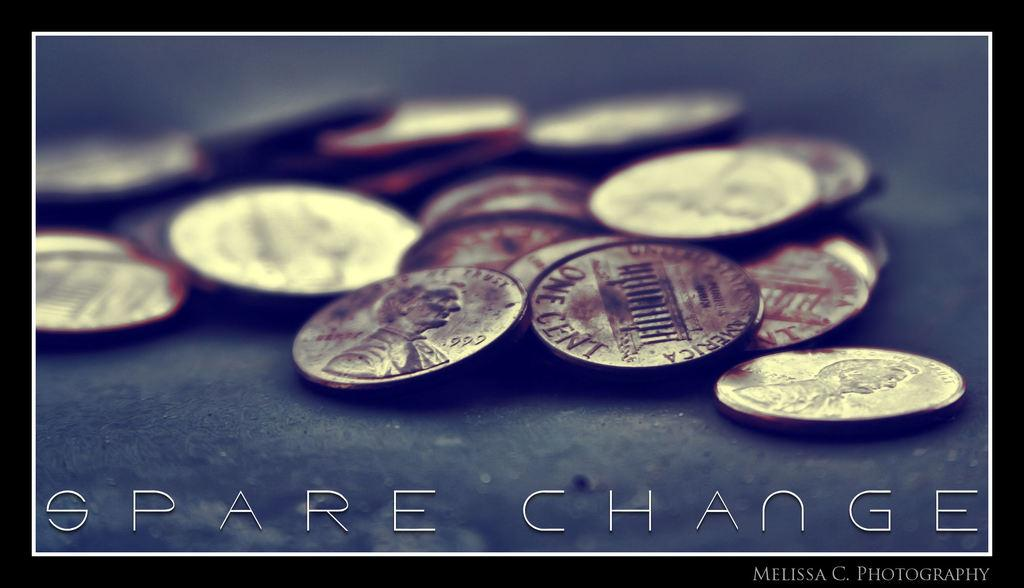<image>
Relay a brief, clear account of the picture shown. a picture of pennies and the words "Spare Change" 